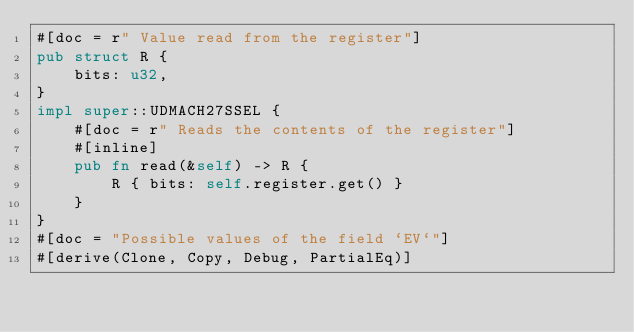Convert code to text. <code><loc_0><loc_0><loc_500><loc_500><_Rust_>#[doc = r" Value read from the register"]
pub struct R {
    bits: u32,
}
impl super::UDMACH27SSEL {
    #[doc = r" Reads the contents of the register"]
    #[inline]
    pub fn read(&self) -> R {
        R { bits: self.register.get() }
    }
}
#[doc = "Possible values of the field `EV`"]
#[derive(Clone, Copy, Debug, PartialEq)]</code> 